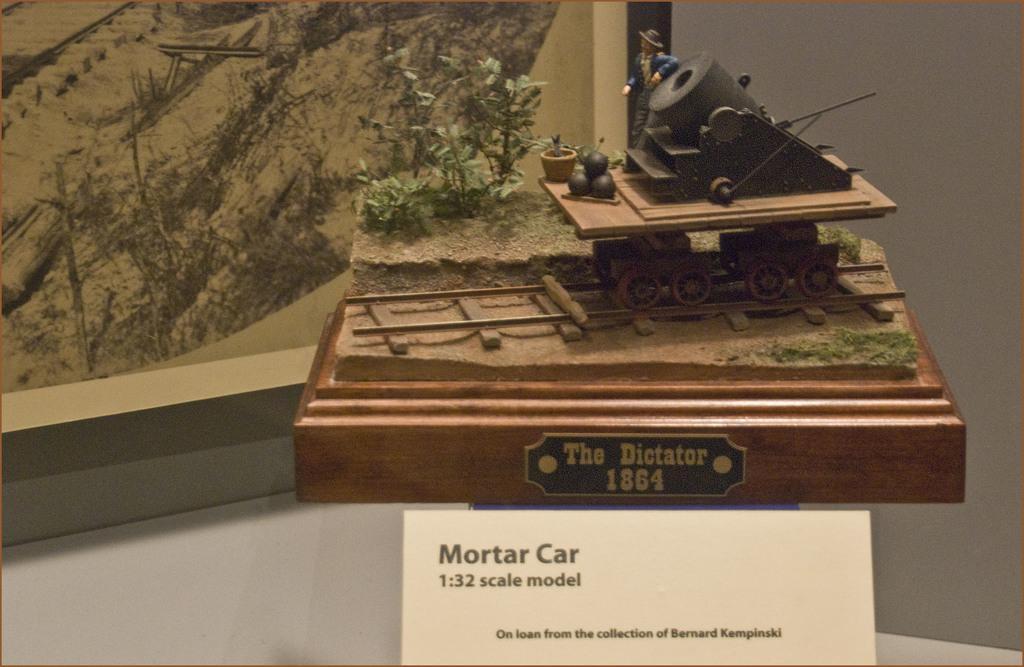How would you summarize this image in a sentence or two? In this image there is a wooden board on which there is a depiction of a cannon on the track and there is a person. There are plants. At the bottom of the image there is a board with some text on it. In the background of the image there is a photo frame on the wall. 